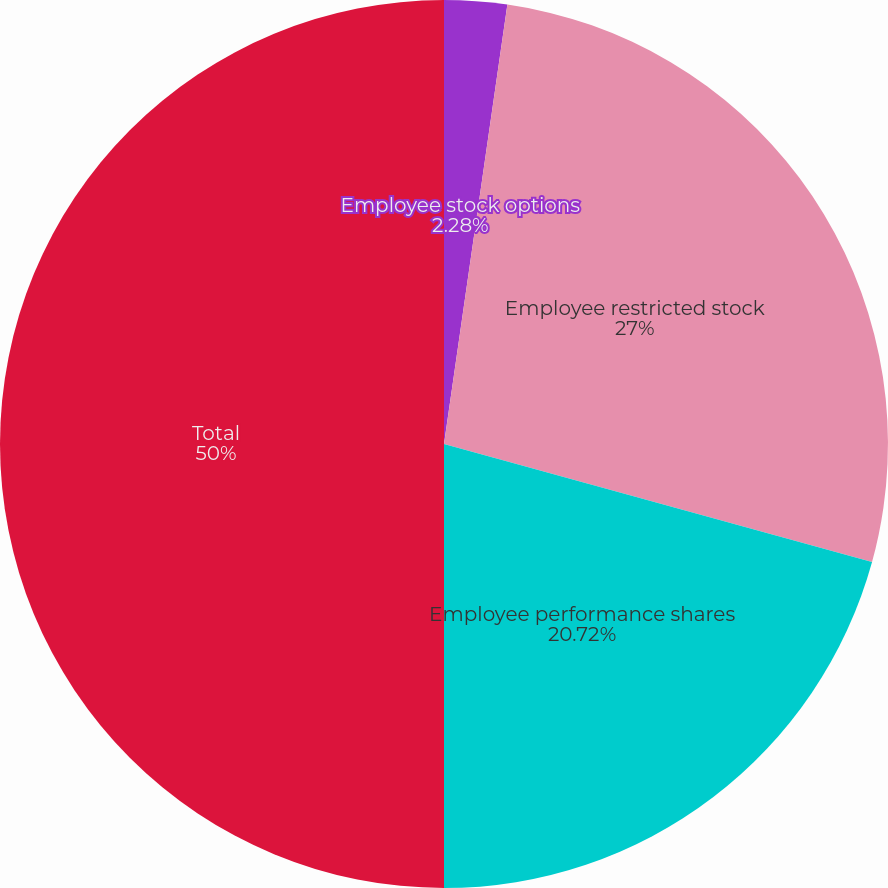Convert chart to OTSL. <chart><loc_0><loc_0><loc_500><loc_500><pie_chart><fcel>Employee stock options<fcel>Employee restricted stock<fcel>Employee performance shares<fcel>Total<nl><fcel>2.28%<fcel>27.0%<fcel>20.72%<fcel>50.0%<nl></chart> 